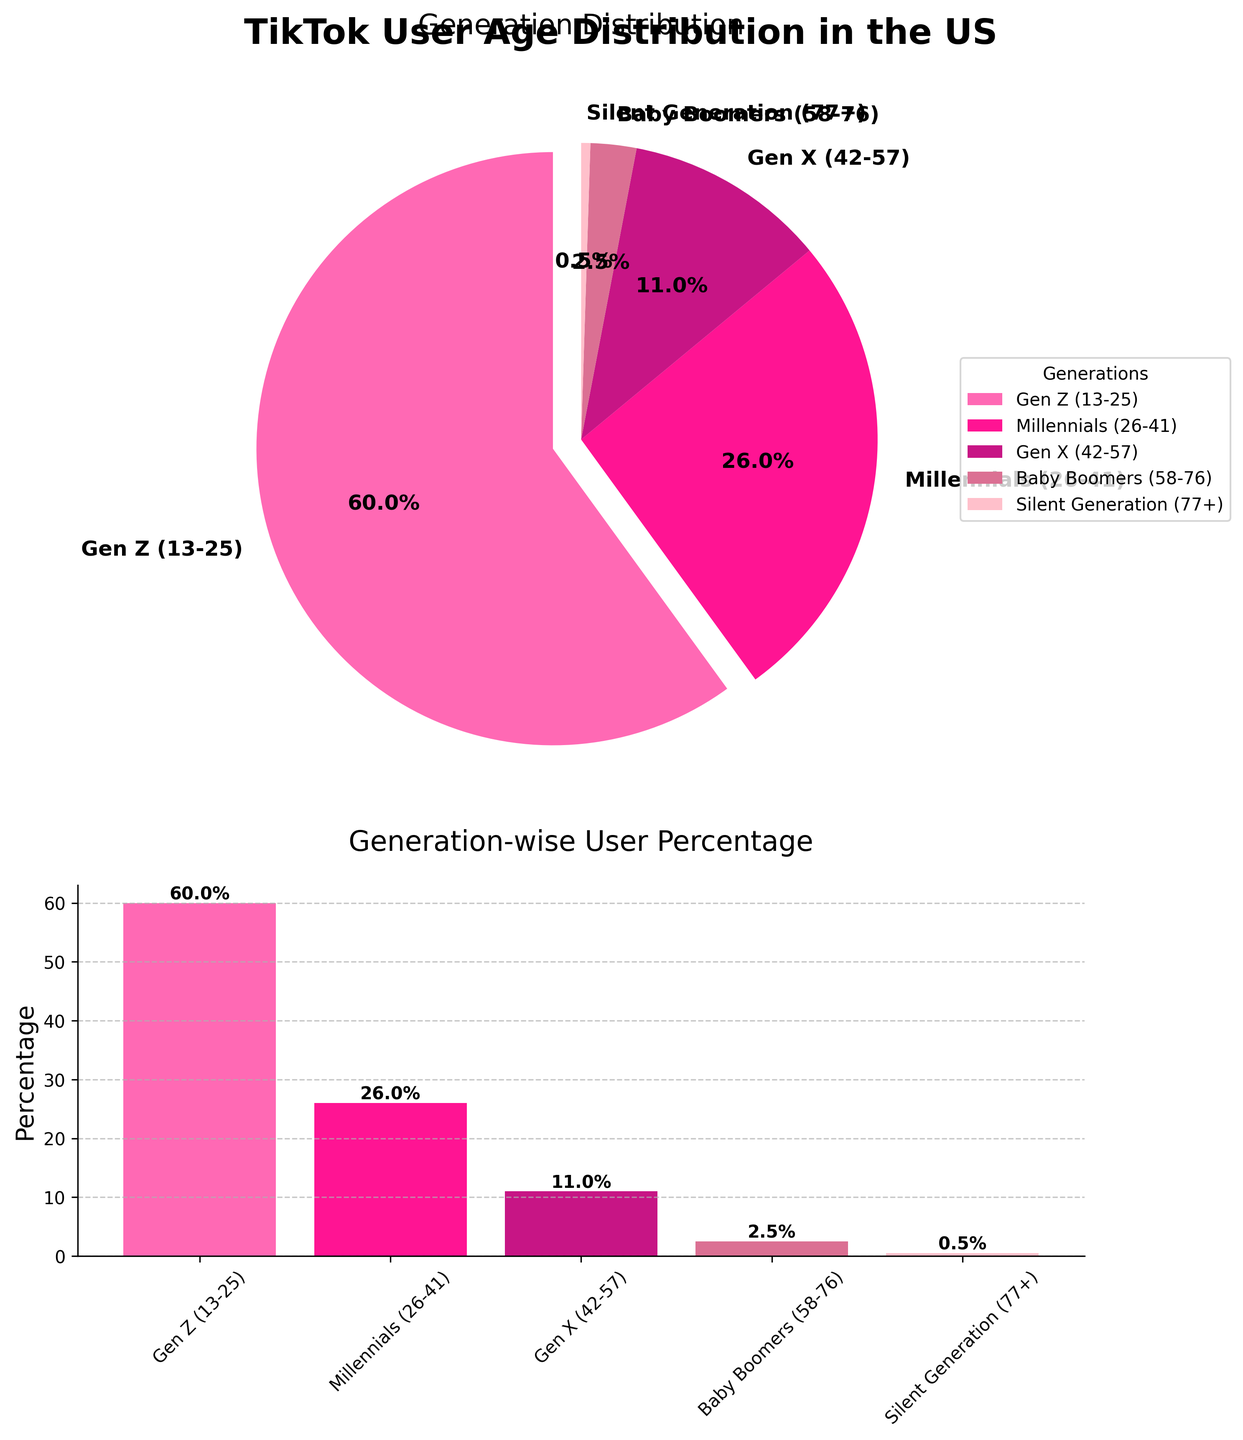What is the percentage of TikTok users in the Silent Generation? Look at the segments of the pie chart or the bars in the bar chart. The Silent Generation is labeled with a 0.5% next to it.
Answer: 0.5% Which generation has the highest percentage of TikTok users? Refer to the pie chart or bar chart. Gen Z has the largest segment and the tallest bar with a percentage of 60%.
Answer: Gen Z How much greater is the percentage of Gen Z users compared to Millennials? Subtract the percentage of Millennials (26%) from the percentage of Gen Z (60%). So, 60% - 26% = 34%.
Answer: 34% Which generation has the shortest bar in the bar chart? Examine the bar chart for the shortest bar. The Silent Generation has the shortest bar with 0.5%.
Answer: Silent Generation Combine the percentages of Gen X and Baby Boomers. What is the total? Add the percentages of Gen X (11%) and Baby Boomers (2.5%). Therefore, 11% + 2.5% = 13.5%.
Answer: 13.5% What is the color of the segment representing Millennials in the pie chart? Locate the segment labeled Millennials in the pie chart. The color is deep pink.
Answer: Deep pink Is the percentage of Millennial users greater than half of the percentage of Gen Z users? Calculate half of the percentage of Gen Z (60% / 2 = 30%) and compare it with the percentage of Millennials (26%). Since 26% is less than 30%, the answer is no.
Answer: No How does the percentage of TikTok users in Gen X compare to that of Baby Boomers? Compare the values: Gen X has 11% and Baby Boomers have 2.5%. Gen X has a greater percentage than Baby Boomers.
Answer: Greater Which generation is represented by the bar that is light pink in color? Identify the corresponding color in the bar chart for the light pink bar. Baby Boomers are represented by this color.
Answer: Baby Boomers If you sum the percentages of Millennials and Silent Generation, does it surpass the percentage of Gen Z? Combine the percentages of Millennials (26%) and Silent Generation (0.5%). The total is 26% + 0.5% = 26.5%, which is less than 60%. So, it does not surpass Gen Z.
Answer: No 